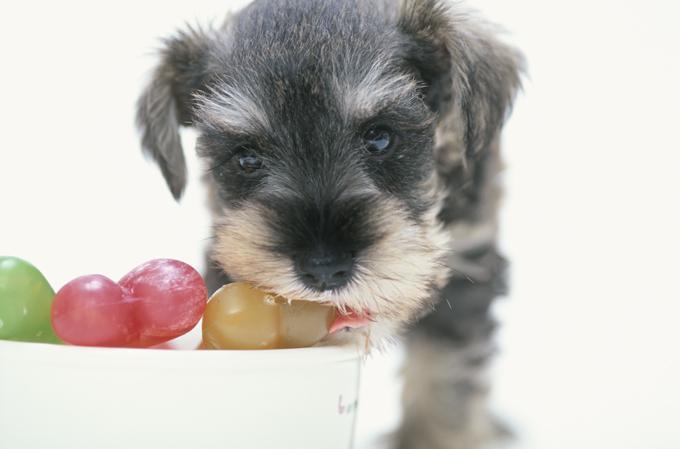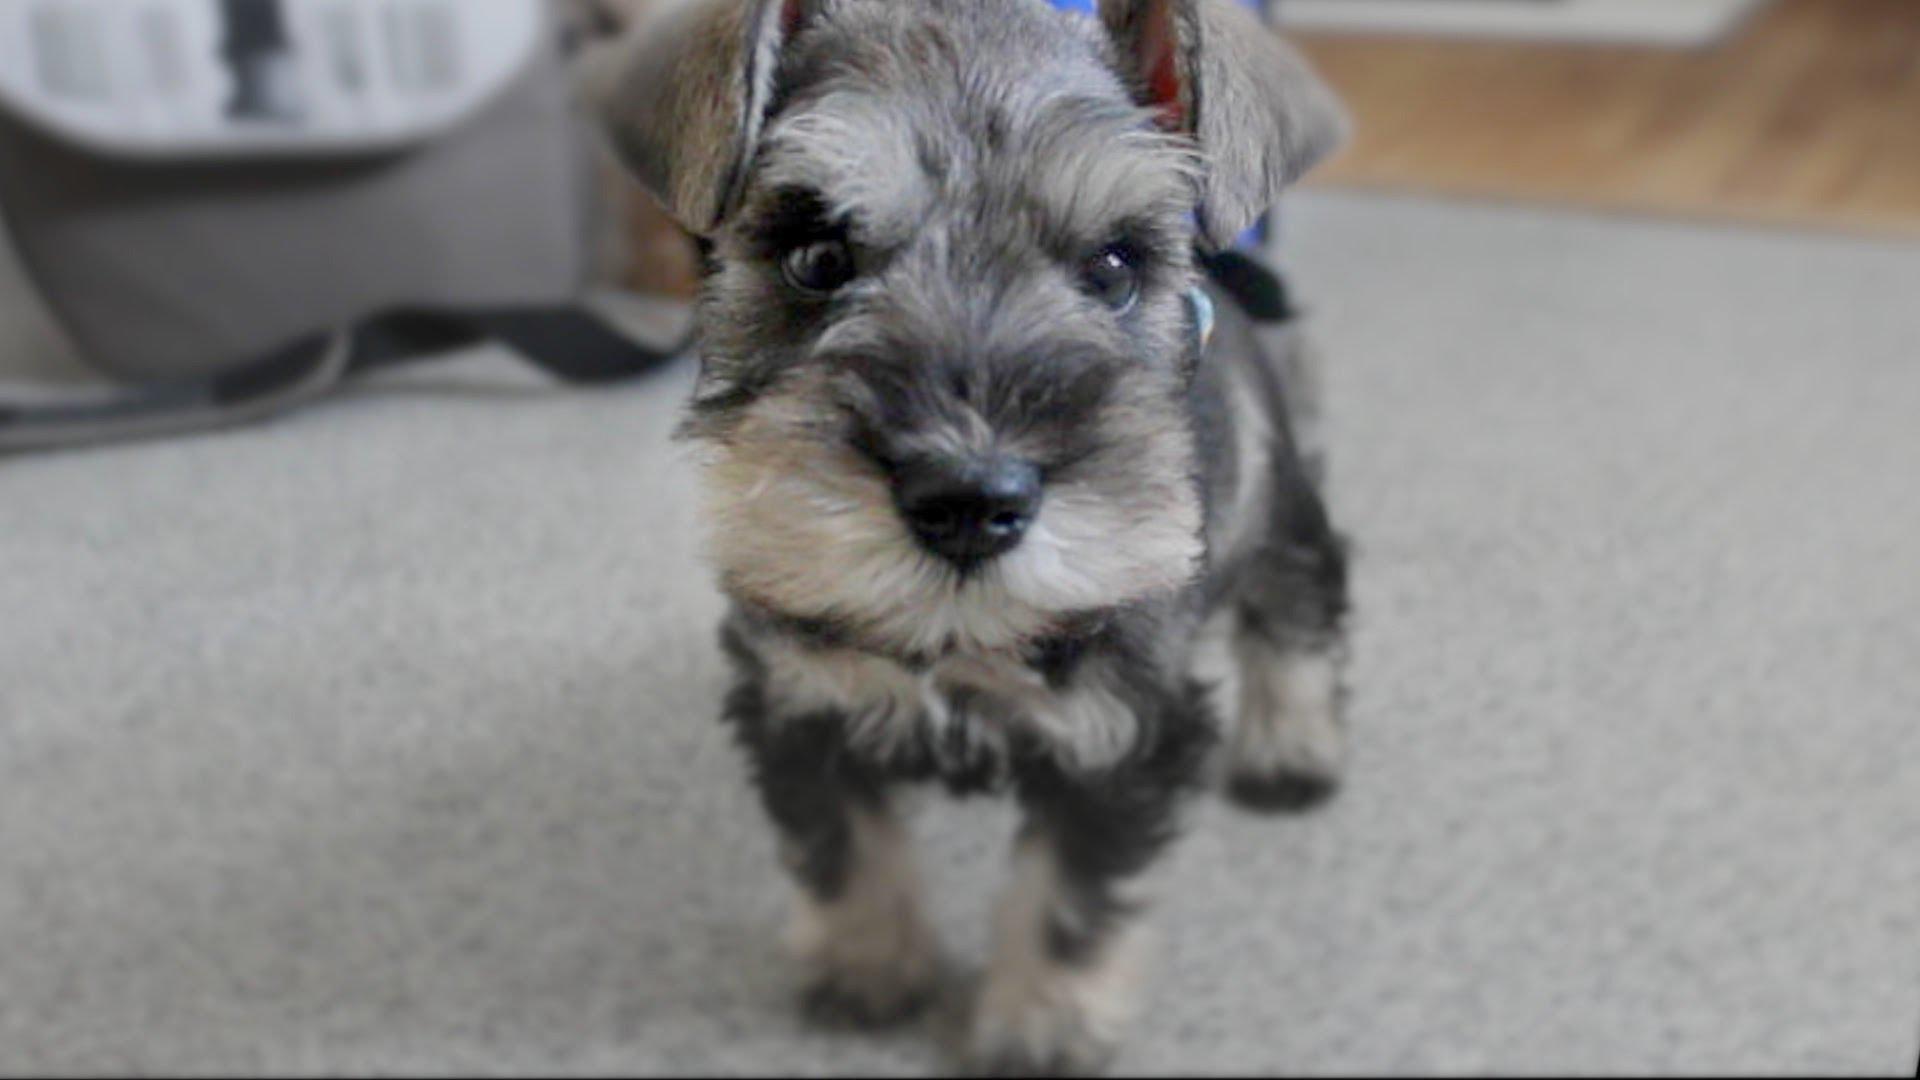The first image is the image on the left, the second image is the image on the right. Examine the images to the left and right. Is the description "All images show dogs outdoors with grass." accurate? Answer yes or no. No. The first image is the image on the left, the second image is the image on the right. Considering the images on both sides, is "In 1 of the images, 1 dog has an object in its mouth." valid? Answer yes or no. Yes. 